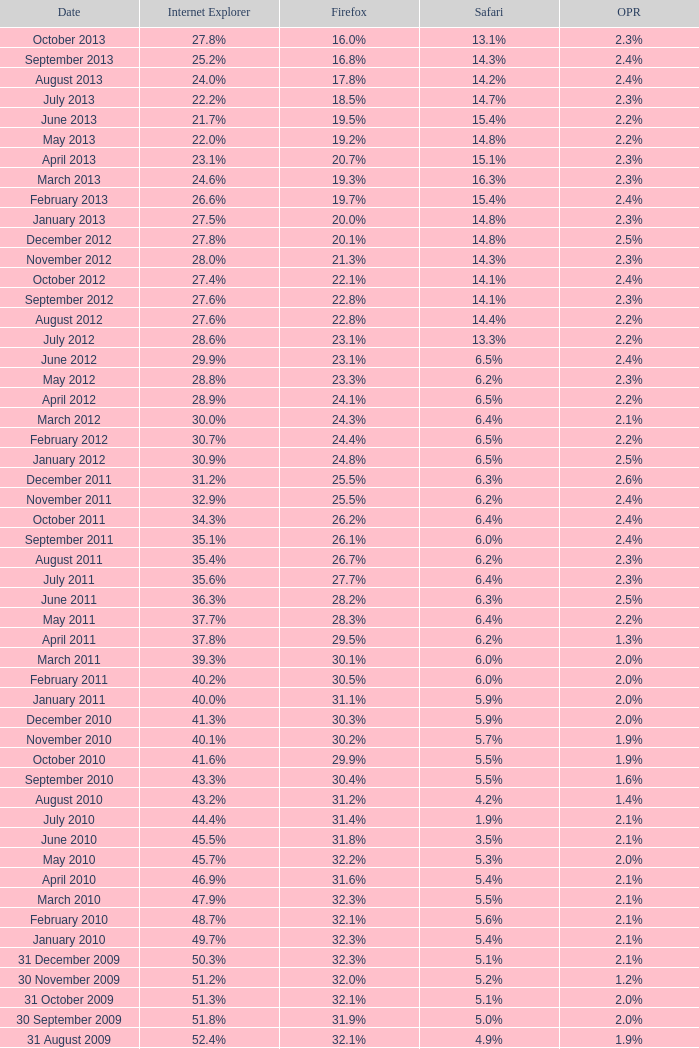What is the firefox value with a 22.0% internet explorer? 19.2%. 